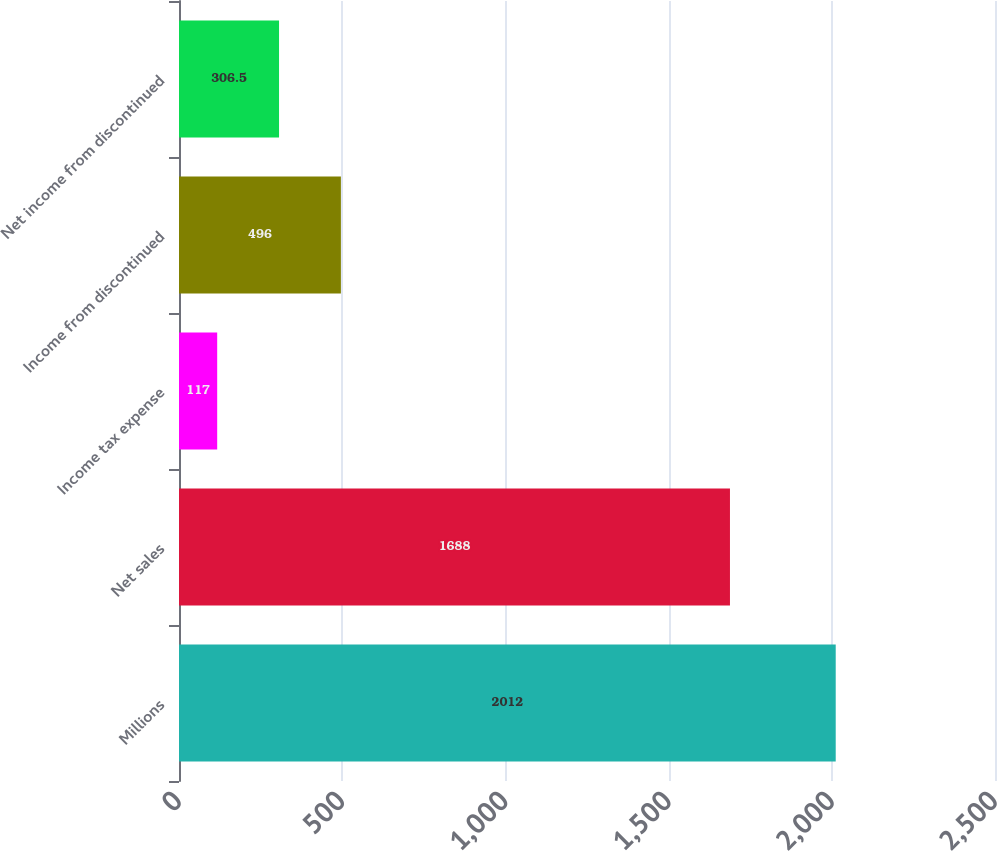Convert chart. <chart><loc_0><loc_0><loc_500><loc_500><bar_chart><fcel>Millions<fcel>Net sales<fcel>Income tax expense<fcel>Income from discontinued<fcel>Net income from discontinued<nl><fcel>2012<fcel>1688<fcel>117<fcel>496<fcel>306.5<nl></chart> 